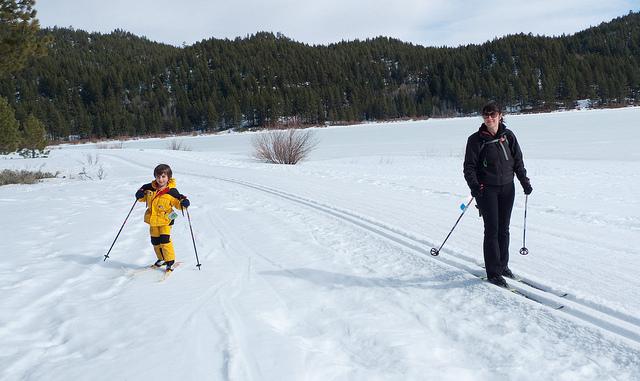Are these two adults?
Be succinct. No. Is the little boy skiing on his own?
Quick response, please. Yes. What kind of trees are in the back?
Give a very brief answer. Pine. 